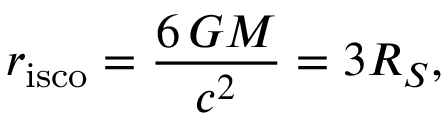Convert formula to latex. <formula><loc_0><loc_0><loc_500><loc_500>r _ { i s c o } = { \frac { 6 \, G M } { c ^ { 2 } } } = 3 R _ { S } ,</formula> 